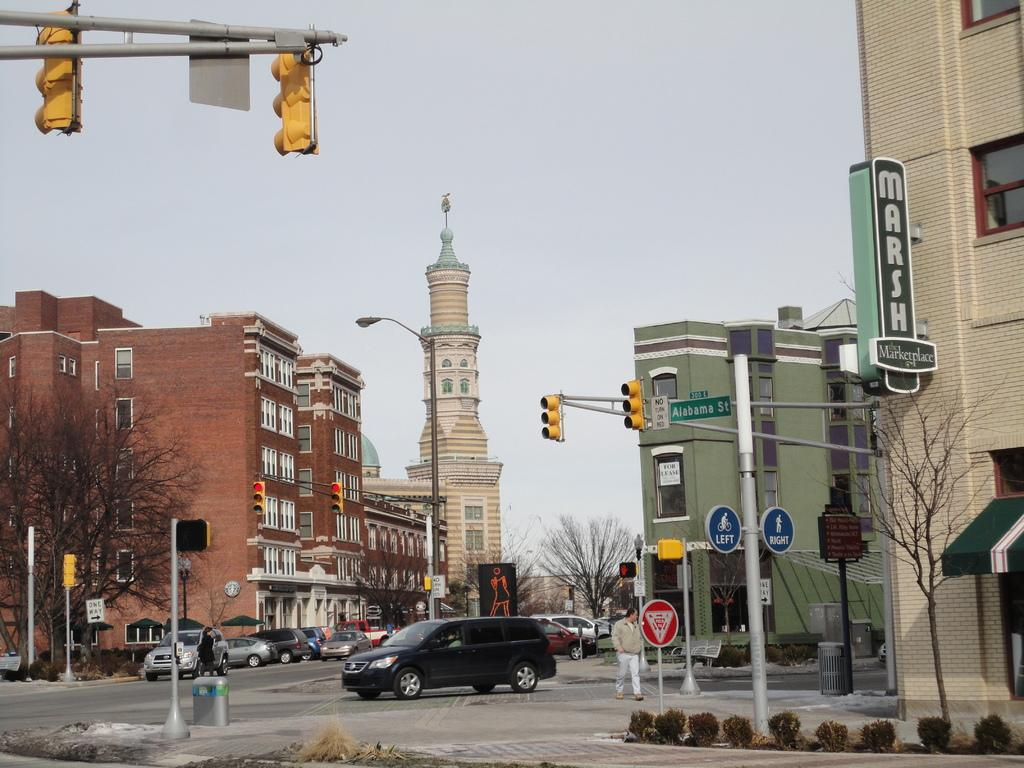<image>
Share a concise interpretation of the image provided. A van is driving through the intersection at Alabama St. 